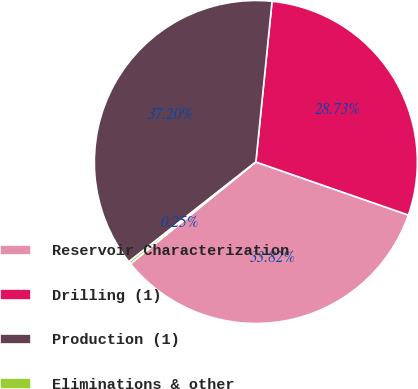Convert chart to OTSL. <chart><loc_0><loc_0><loc_500><loc_500><pie_chart><fcel>Reservoir Characterization<fcel>Drilling (1)<fcel>Production (1)<fcel>Eliminations & other<nl><fcel>33.82%<fcel>28.73%<fcel>37.2%<fcel>0.25%<nl></chart> 